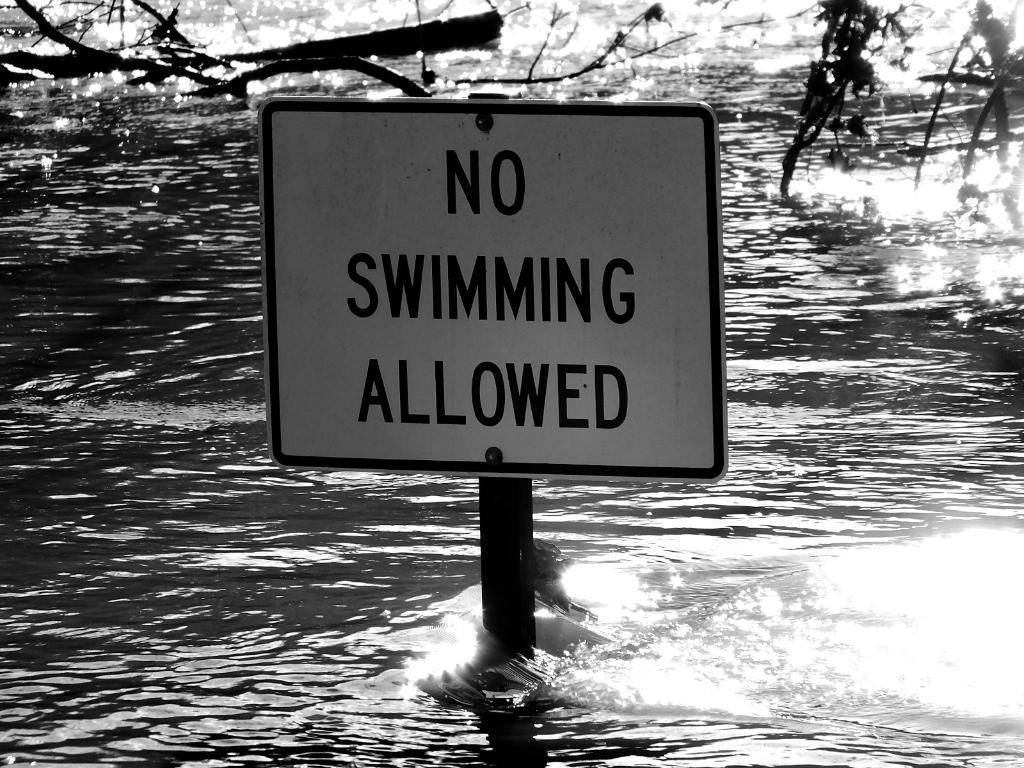How would you summarize this image in a sentence or two? In this image, in the middle, we can see a board. In the background, we can see some trees. At the bottom, we can see a water in the lake. 